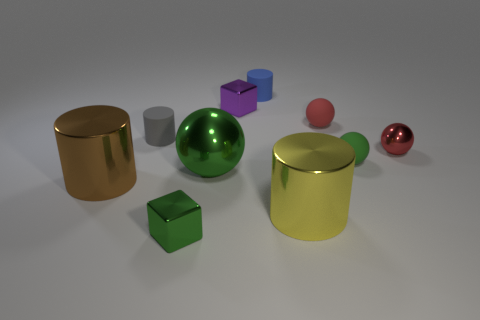Subtract all cubes. How many objects are left? 8 Subtract all green metal objects. Subtract all purple metal cubes. How many objects are left? 7 Add 2 tiny blue rubber cylinders. How many tiny blue rubber cylinders are left? 3 Add 6 brown things. How many brown things exist? 7 Subtract 0 blue balls. How many objects are left? 10 